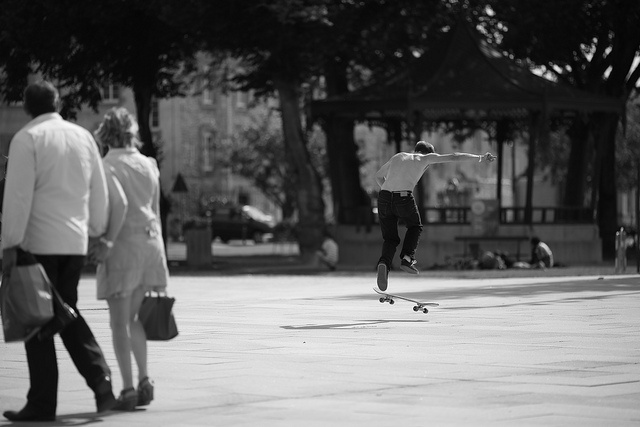Describe the objects in this image and their specific colors. I can see people in black, gray, dimgray, and lightgray tones, people in black, gray, darkgray, and lightgray tones, people in black, dimgray, gray, and lightgray tones, handbag in black, gray, darkgray, and lightgray tones, and car in black, gray, darkgray, and lightgray tones in this image. 